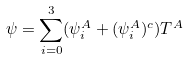<formula> <loc_0><loc_0><loc_500><loc_500>\psi = \sum _ { i = 0 } ^ { 3 } ( \psi _ { i } ^ { A } + ( \psi _ { i } ^ { A } ) ^ { c } ) T ^ { A }</formula> 